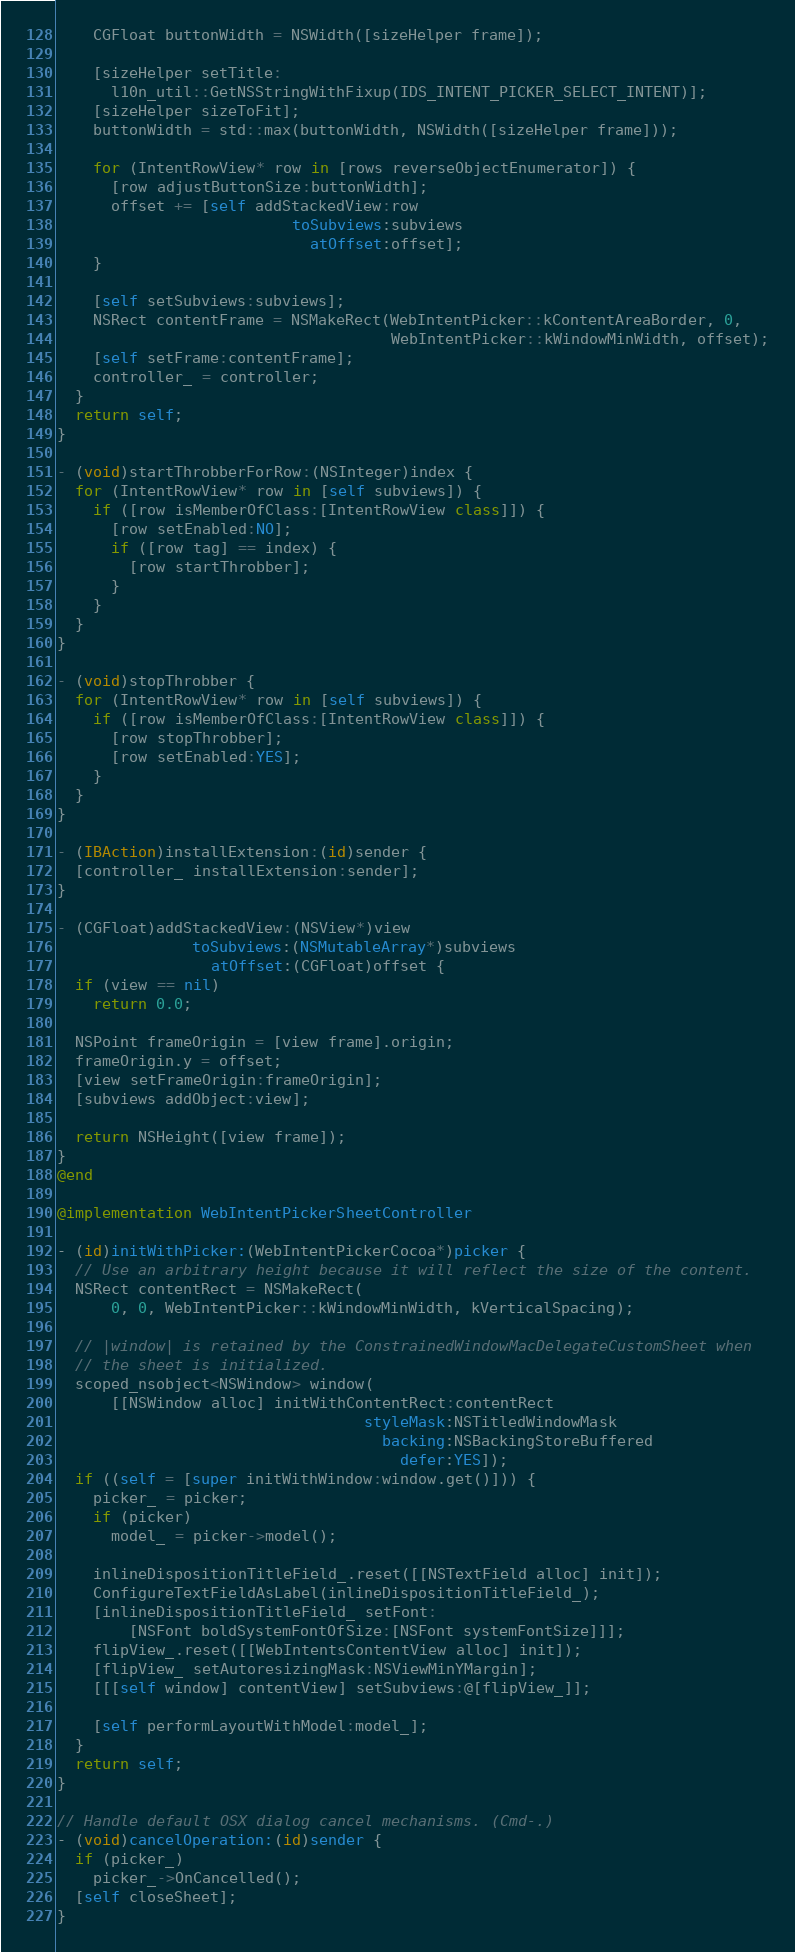Convert code to text. <code><loc_0><loc_0><loc_500><loc_500><_ObjectiveC_>    CGFloat buttonWidth = NSWidth([sizeHelper frame]);

    [sizeHelper setTitle:
      l10n_util::GetNSStringWithFixup(IDS_INTENT_PICKER_SELECT_INTENT)];
    [sizeHelper sizeToFit];
    buttonWidth = std::max(buttonWidth, NSWidth([sizeHelper frame]));

    for (IntentRowView* row in [rows reverseObjectEnumerator]) {
      [row adjustButtonSize:buttonWidth];
      offset += [self addStackedView:row
                          toSubviews:subviews
                            atOffset:offset];
    }

    [self setSubviews:subviews];
    NSRect contentFrame = NSMakeRect(WebIntentPicker::kContentAreaBorder, 0,
                                     WebIntentPicker::kWindowMinWidth, offset);
    [self setFrame:contentFrame];
    controller_ = controller;
  }
  return self;
}

- (void)startThrobberForRow:(NSInteger)index {
  for (IntentRowView* row in [self subviews]) {
    if ([row isMemberOfClass:[IntentRowView class]]) {
      [row setEnabled:NO];
      if ([row tag] == index) {
        [row startThrobber];
      }
    }
  }
}

- (void)stopThrobber {
  for (IntentRowView* row in [self subviews]) {
    if ([row isMemberOfClass:[IntentRowView class]]) {
      [row stopThrobber];
      [row setEnabled:YES];
    }
  }
}

- (IBAction)installExtension:(id)sender {
  [controller_ installExtension:sender];
}

- (CGFloat)addStackedView:(NSView*)view
               toSubviews:(NSMutableArray*)subviews
                 atOffset:(CGFloat)offset {
  if (view == nil)
    return 0.0;

  NSPoint frameOrigin = [view frame].origin;
  frameOrigin.y = offset;
  [view setFrameOrigin:frameOrigin];
  [subviews addObject:view];

  return NSHeight([view frame]);
}
@end

@implementation WebIntentPickerSheetController

- (id)initWithPicker:(WebIntentPickerCocoa*)picker {
  // Use an arbitrary height because it will reflect the size of the content.
  NSRect contentRect = NSMakeRect(
      0, 0, WebIntentPicker::kWindowMinWidth, kVerticalSpacing);

  // |window| is retained by the ConstrainedWindowMacDelegateCustomSheet when
  // the sheet is initialized.
  scoped_nsobject<NSWindow> window(
      [[NSWindow alloc] initWithContentRect:contentRect
                                  styleMask:NSTitledWindowMask
                                    backing:NSBackingStoreBuffered
                                      defer:YES]);
  if ((self = [super initWithWindow:window.get()])) {
    picker_ = picker;
    if (picker)
      model_ = picker->model();

    inlineDispositionTitleField_.reset([[NSTextField alloc] init]);
    ConfigureTextFieldAsLabel(inlineDispositionTitleField_);
    [inlineDispositionTitleField_ setFont:
        [NSFont boldSystemFontOfSize:[NSFont systemFontSize]]];
    flipView_.reset([[WebIntentsContentView alloc] init]);
    [flipView_ setAutoresizingMask:NSViewMinYMargin];
    [[[self window] contentView] setSubviews:@[flipView_]];

    [self performLayoutWithModel:model_];
  }
  return self;
}

// Handle default OSX dialog cancel mechanisms. (Cmd-.)
- (void)cancelOperation:(id)sender {
  if (picker_)
    picker_->OnCancelled();
  [self closeSheet];
}
</code> 